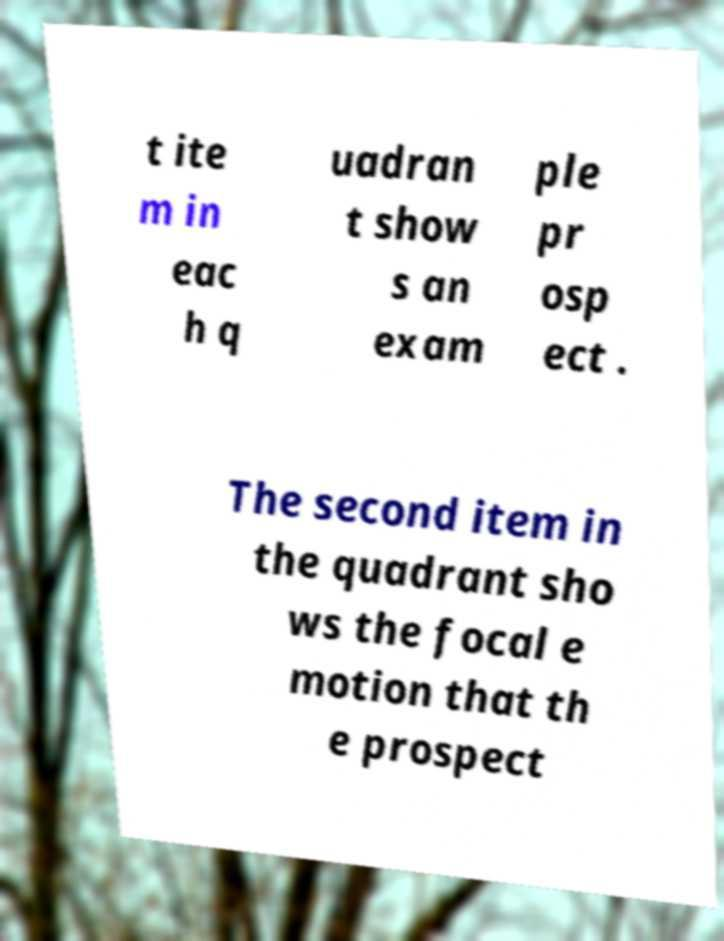There's text embedded in this image that I need extracted. Can you transcribe it verbatim? t ite m in eac h q uadran t show s an exam ple pr osp ect . The second item in the quadrant sho ws the focal e motion that th e prospect 